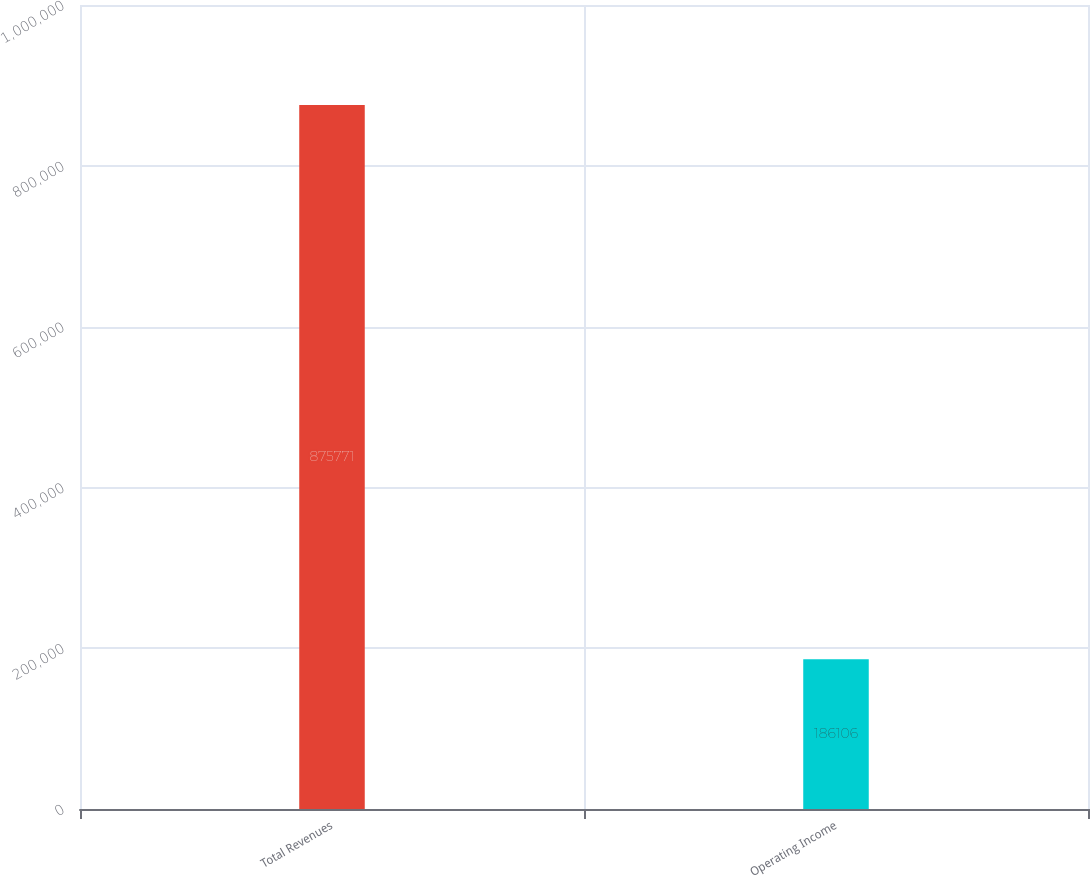Convert chart to OTSL. <chart><loc_0><loc_0><loc_500><loc_500><bar_chart><fcel>Total Revenues<fcel>Operating Income<nl><fcel>875771<fcel>186106<nl></chart> 